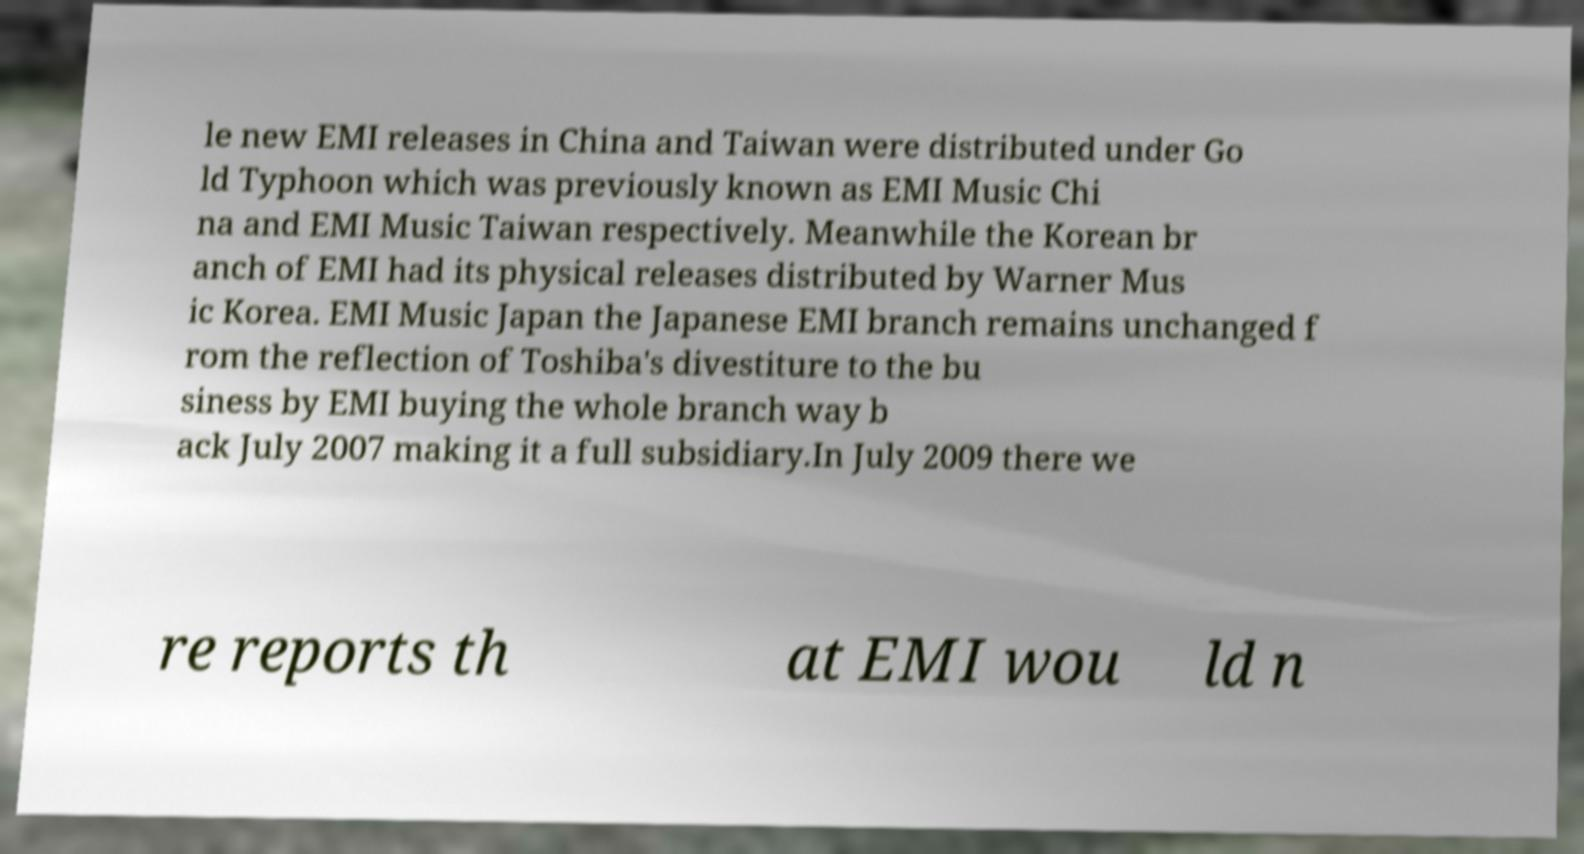Could you assist in decoding the text presented in this image and type it out clearly? le new EMI releases in China and Taiwan were distributed under Go ld Typhoon which was previously known as EMI Music Chi na and EMI Music Taiwan respectively. Meanwhile the Korean br anch of EMI had its physical releases distributed by Warner Mus ic Korea. EMI Music Japan the Japanese EMI branch remains unchanged f rom the reflection of Toshiba's divestiture to the bu siness by EMI buying the whole branch way b ack July 2007 making it a full subsidiary.In July 2009 there we re reports th at EMI wou ld n 